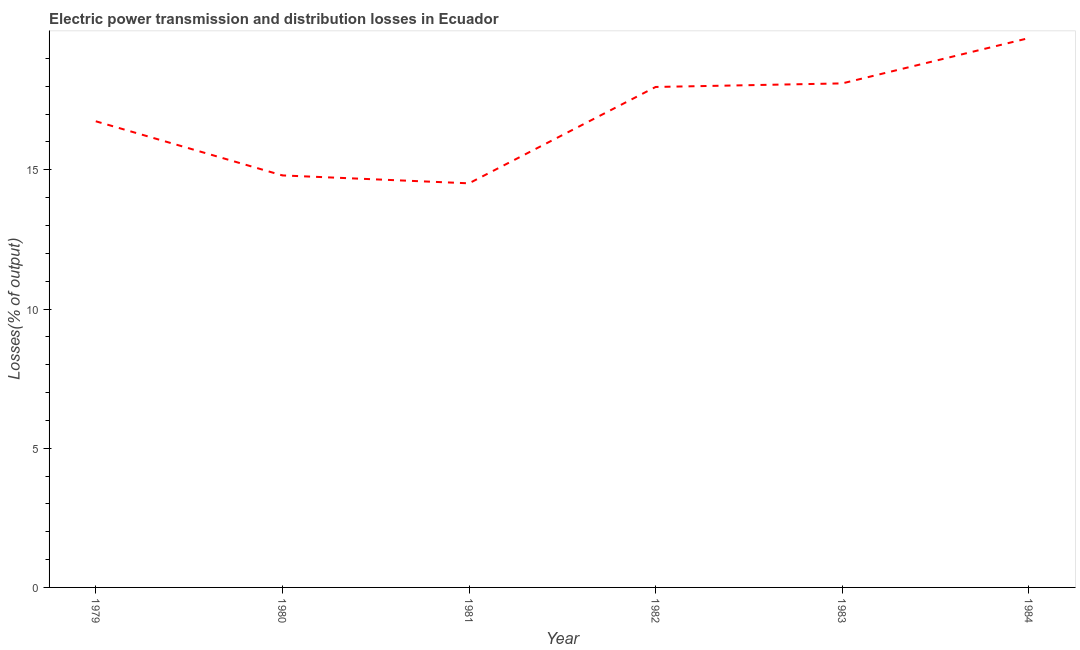What is the electric power transmission and distribution losses in 1982?
Your response must be concise. 17.98. Across all years, what is the maximum electric power transmission and distribution losses?
Offer a terse response. 19.73. Across all years, what is the minimum electric power transmission and distribution losses?
Offer a very short reply. 14.51. What is the sum of the electric power transmission and distribution losses?
Provide a succinct answer. 101.87. What is the difference between the electric power transmission and distribution losses in 1982 and 1984?
Your response must be concise. -1.76. What is the average electric power transmission and distribution losses per year?
Keep it short and to the point. 16.98. What is the median electric power transmission and distribution losses?
Your answer should be compact. 17.36. Do a majority of the years between 1984 and 1983 (inclusive) have electric power transmission and distribution losses greater than 13 %?
Offer a terse response. No. What is the ratio of the electric power transmission and distribution losses in 1979 to that in 1980?
Provide a short and direct response. 1.13. Is the difference between the electric power transmission and distribution losses in 1980 and 1982 greater than the difference between any two years?
Offer a terse response. No. What is the difference between the highest and the second highest electric power transmission and distribution losses?
Provide a succinct answer. 1.63. Is the sum of the electric power transmission and distribution losses in 1983 and 1984 greater than the maximum electric power transmission and distribution losses across all years?
Offer a very short reply. Yes. What is the difference between the highest and the lowest electric power transmission and distribution losses?
Offer a terse response. 5.22. In how many years, is the electric power transmission and distribution losses greater than the average electric power transmission and distribution losses taken over all years?
Your response must be concise. 3. How many years are there in the graph?
Offer a terse response. 6. What is the title of the graph?
Offer a terse response. Electric power transmission and distribution losses in Ecuador. What is the label or title of the Y-axis?
Your answer should be very brief. Losses(% of output). What is the Losses(% of output) of 1979?
Give a very brief answer. 16.74. What is the Losses(% of output) in 1980?
Keep it short and to the point. 14.8. What is the Losses(% of output) of 1981?
Provide a succinct answer. 14.51. What is the Losses(% of output) of 1982?
Provide a succinct answer. 17.98. What is the Losses(% of output) in 1983?
Ensure brevity in your answer.  18.1. What is the Losses(% of output) of 1984?
Your answer should be compact. 19.73. What is the difference between the Losses(% of output) in 1979 and 1980?
Your answer should be very brief. 1.94. What is the difference between the Losses(% of output) in 1979 and 1981?
Your answer should be very brief. 2.23. What is the difference between the Losses(% of output) in 1979 and 1982?
Your response must be concise. -1.23. What is the difference between the Losses(% of output) in 1979 and 1983?
Your answer should be very brief. -1.36. What is the difference between the Losses(% of output) in 1979 and 1984?
Give a very brief answer. -2.99. What is the difference between the Losses(% of output) in 1980 and 1981?
Ensure brevity in your answer.  0.28. What is the difference between the Losses(% of output) in 1980 and 1982?
Your answer should be very brief. -3.18. What is the difference between the Losses(% of output) in 1980 and 1983?
Ensure brevity in your answer.  -3.31. What is the difference between the Losses(% of output) in 1980 and 1984?
Provide a short and direct response. -4.93. What is the difference between the Losses(% of output) in 1981 and 1982?
Your response must be concise. -3.46. What is the difference between the Losses(% of output) in 1981 and 1983?
Your response must be concise. -3.59. What is the difference between the Losses(% of output) in 1981 and 1984?
Keep it short and to the point. -5.22. What is the difference between the Losses(% of output) in 1982 and 1983?
Keep it short and to the point. -0.13. What is the difference between the Losses(% of output) in 1982 and 1984?
Your response must be concise. -1.76. What is the difference between the Losses(% of output) in 1983 and 1984?
Make the answer very short. -1.63. What is the ratio of the Losses(% of output) in 1979 to that in 1980?
Offer a terse response. 1.13. What is the ratio of the Losses(% of output) in 1979 to that in 1981?
Provide a short and direct response. 1.15. What is the ratio of the Losses(% of output) in 1979 to that in 1983?
Offer a terse response. 0.93. What is the ratio of the Losses(% of output) in 1979 to that in 1984?
Ensure brevity in your answer.  0.85. What is the ratio of the Losses(% of output) in 1980 to that in 1981?
Provide a short and direct response. 1.02. What is the ratio of the Losses(% of output) in 1980 to that in 1982?
Provide a succinct answer. 0.82. What is the ratio of the Losses(% of output) in 1980 to that in 1983?
Your answer should be very brief. 0.82. What is the ratio of the Losses(% of output) in 1980 to that in 1984?
Offer a very short reply. 0.75. What is the ratio of the Losses(% of output) in 1981 to that in 1982?
Ensure brevity in your answer.  0.81. What is the ratio of the Losses(% of output) in 1981 to that in 1983?
Your response must be concise. 0.8. What is the ratio of the Losses(% of output) in 1981 to that in 1984?
Your response must be concise. 0.74. What is the ratio of the Losses(% of output) in 1982 to that in 1984?
Make the answer very short. 0.91. What is the ratio of the Losses(% of output) in 1983 to that in 1984?
Your answer should be compact. 0.92. 